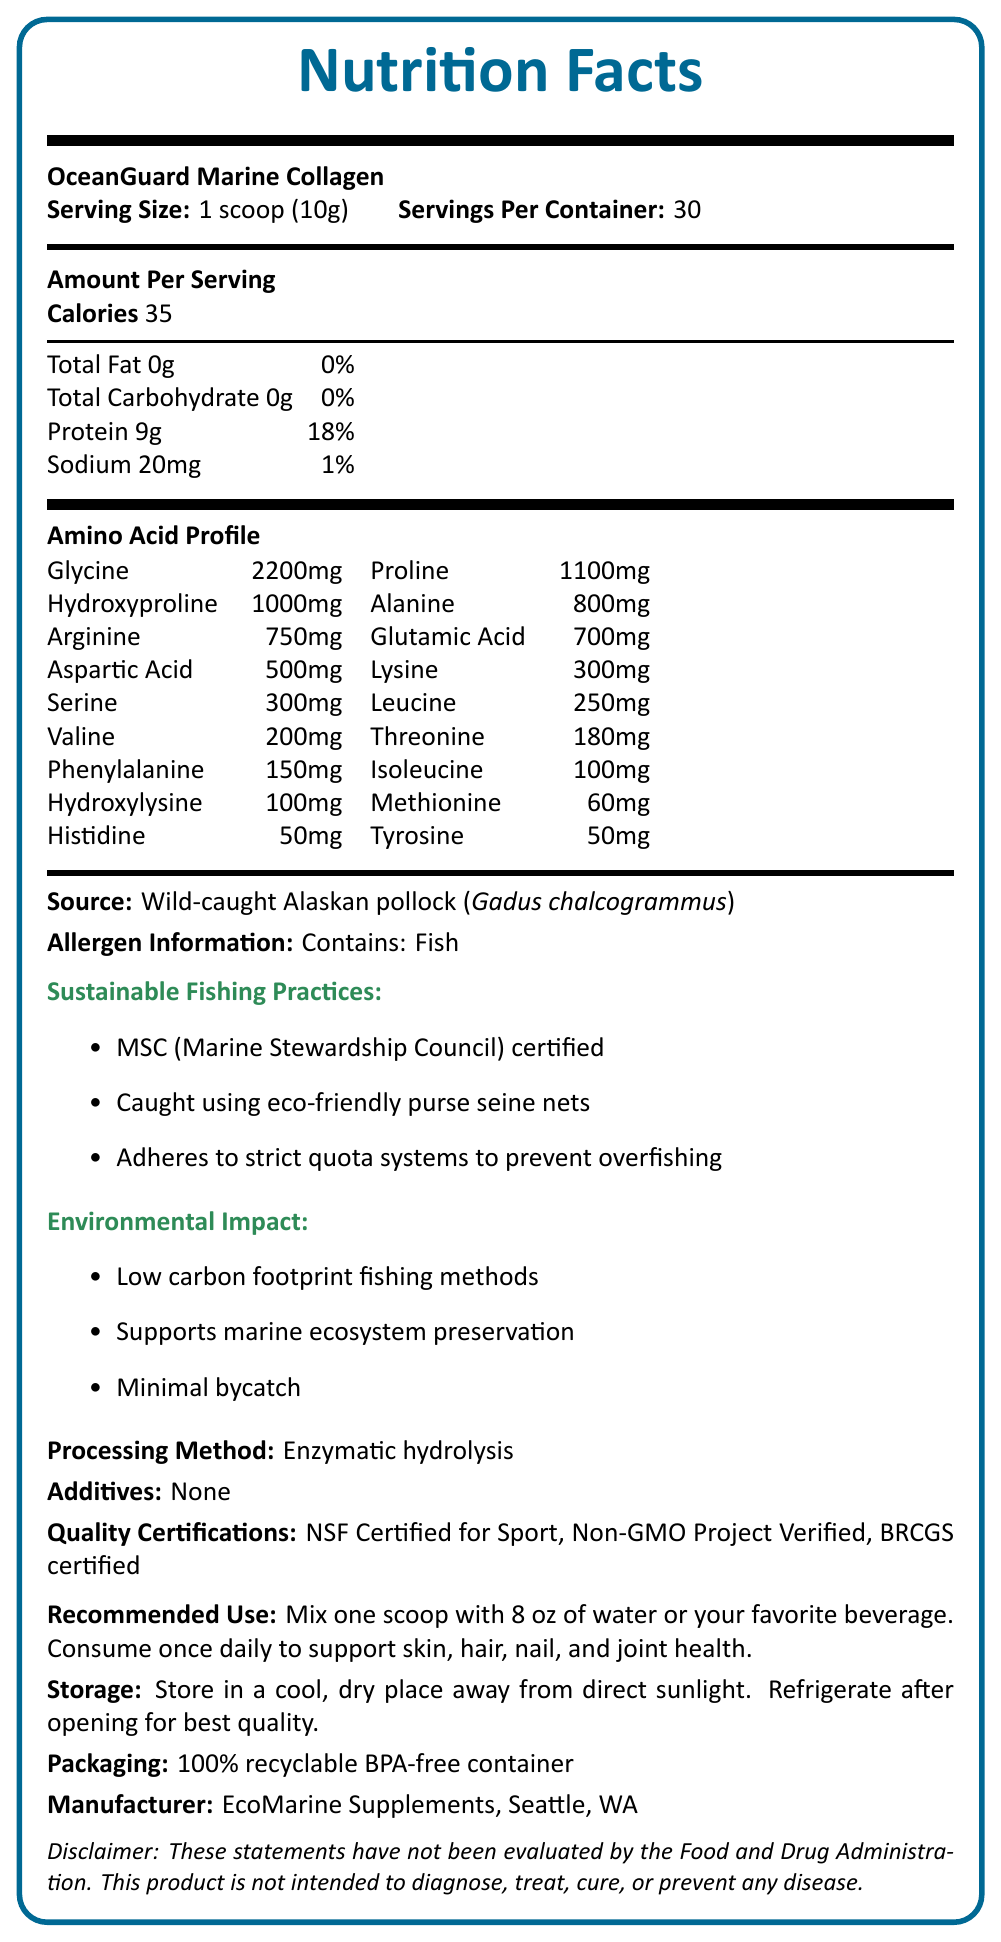How many calories are there per serving? The document states that there are 35 calories per serving.
Answer: 35 What is the serving size of OceanGuard Marine Collagen? The serving size is clearly mentioned as 1 scoop (10g) in the document.
Answer: 1 scoop (10g) Which fish is the source of this marine collagen supplement? The source is specified as Wild-caught Alaskan pollock (Gadus chalcogrammus).
Answer: Wild-caught Alaskan pollock (Gadus chalcogrammus) What are the total carbohydrates per serving of OceanGuard Marine Collagen? The document lists the total carbohydrates per serving as 0g.
Answer: 0g How much protein is found in one serving? The document specifies that there are 9g of protein per serving.
Answer: 9g True or False: The product contains dairy. The allergen information only mentions fish, not dairy.
Answer: False Which certification ensures that the fishing practices are eco-friendly? A. Fair Trade B. MSC (Marine Stewardship Council) C. USDA Organic The document lists MSC (Marine Stewardship Council) certification as an indicator of sustainable fishing practices.
Answer: B How much glycine is present in the amino acid profile? The document lists glycine as 2200mg per serving in the amino acid profile.
Answer: 2200mg What is the recommended daily use for OceanGuard Marine Collagen? The document advises to mix one scoop with 8 oz of water or a favorite beverage and consume once daily.
Answer: Mix one scoop with 8 oz of water or your favorite beverage. Consume once daily. What processing method is used for this marine collagen supplement? The document states that enzymatic hydrolysis is the processing method used.
Answer: Enzymatic hydrolysis What environmental impacts are listed for the product? The document states three environmental impacts: low carbon footprint fishing methods, supports marine ecosystem preservation, and minimal bycatch.
Answer: Low carbon footprint fishing methods, Supports marine ecosystem preservation, Minimal bycatch Who is the manufacturer of OceanGuard Marine Collagen? The manufacturer's name and location are listed as EcoMarine Supplements, Seattle, WA.
Answer: EcoMarine Supplements, Seattle, WA Which of the following quality certifications does the product have? A. Fair Trade B. Non-GMO Project Verified C. USDA Organic D. BRCGS certified The document notes that the product is Non-GMO Project Verified and BRCGS certified, among other certifications.
Answer: B, D Are there any additives in OceanGuard Marine Collagen? The document states that there are no additives in the product.
Answer: None Can you store the product at room temperature after opening? The storage instructions recommend refrigerating the product after opening for best quality.
Answer: No, it is recommended to refrigerate after opening for best quality. Summarize the main idea of this document. The document encompasses all necessary information regarding the product's nutritional content, sourcing practices, environmental considerations, and usage guidelines.
Answer: The document provides detailed nutrition facts, ingredient sources, environmental impact, sustainable fishing practices, processing methods, allergen information, usage instructions, storage guidelines, and quality certifications for OceanGuard Marine Collagen derived from wild-caught Alaskan pollock. What is the net weight of the entire container? The document mentions serving size and number of servings but does not provide the total net weight of the container.
Answer: Not enough information What is the sodium content per serving, and how does it contribute to the daily value percentage? The document lists sodium content as 20mg per serving, contributing to 1% of the daily value.
Answer: 20mg, 1% Which amino acid is present in the highest amount and what is its quantity? The amino acid profile lists glycine as the highest, with a quantity of 2200mg.
Answer: Glycine, 2200mg 